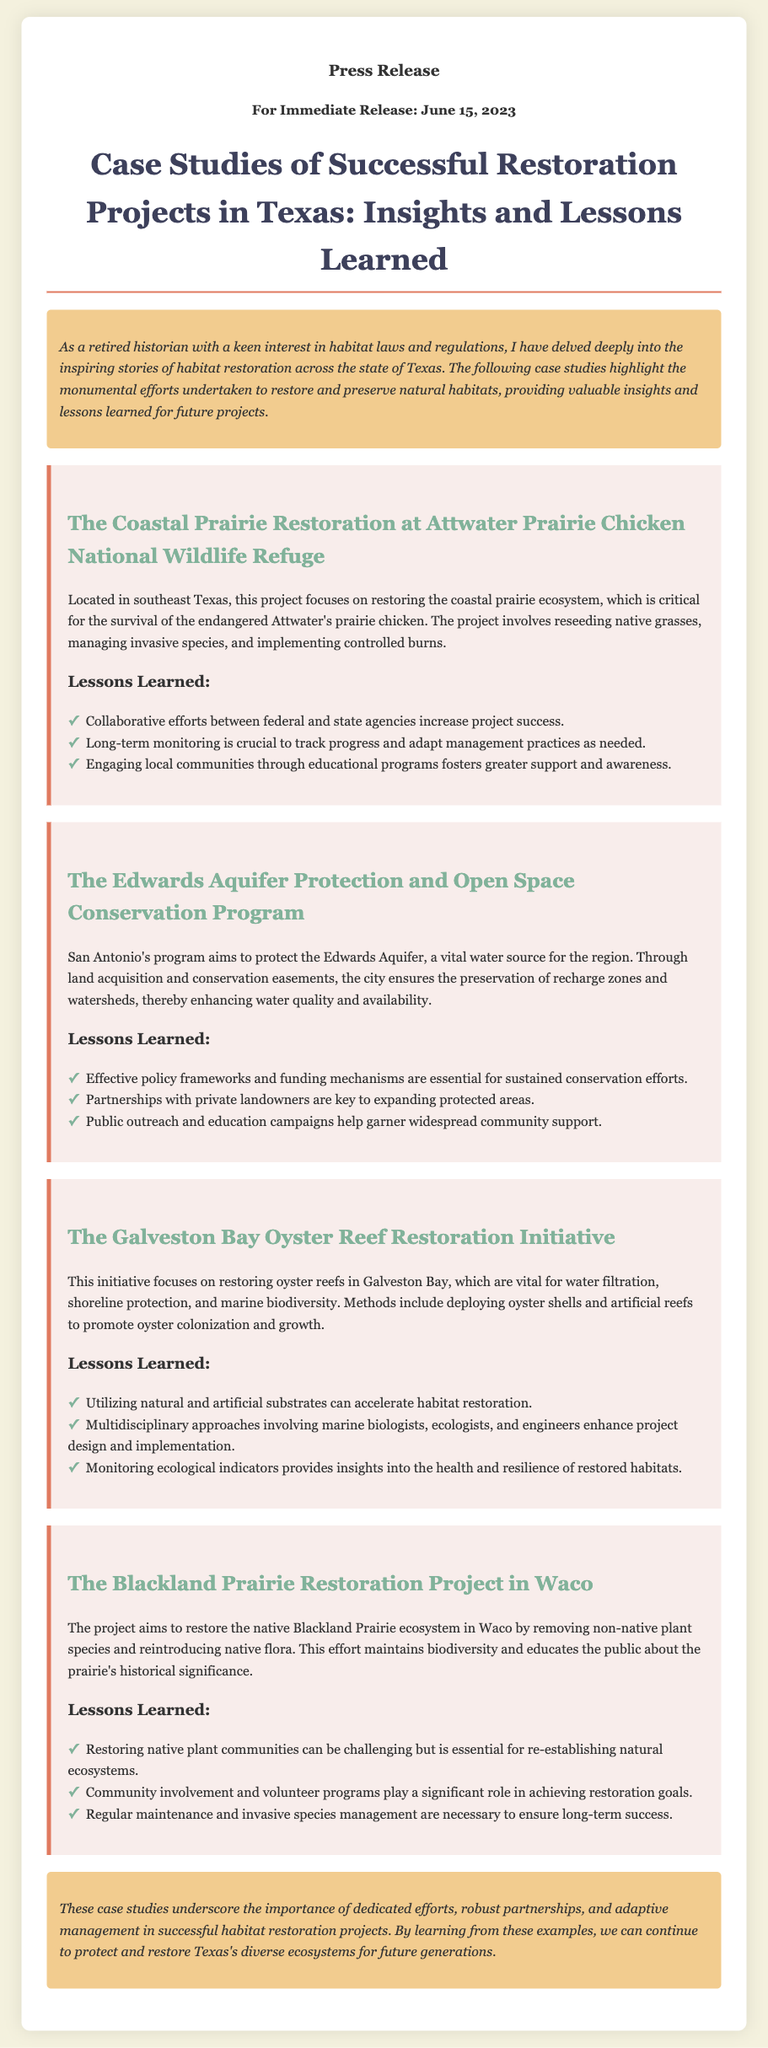What is the title of the press release? The title of the press release provides information about the content covered, which is "Case Studies of Successful Restoration Projects in Texas: Insights and Lessons Learned."
Answer: Case Studies of Successful Restoration Projects in Texas: Insights and Lessons Learned When was the press release issued? The date of the press release is provided at the top, indicating when it was made available to the public.
Answer: June 15, 2023 What is the main focus of the coastal prairie restoration project? The main focus is to restore the coastal prairie ecosystem, critical for the survival of the endangered species mentioned.
Answer: Endangered Attwater's prairie chicken What are two key lessons learned from the Edwards Aquifer project? Two lessons learned from the Edwards Aquifer project highlight the importance of policy frameworks and partnerships with landowners.
Answer: Effective policy frameworks and funding mechanisms; Partnerships with private landowners Which ecosystem is being restored in the Blackland Prairie Restoration Project? The specific ecosystem being restored is highlighted at the beginning of the corresponding case study.
Answer: Blackland Prairie Ecosystem What type of restoration methods are used in the Galveston Bay initiative? The types of restoration methods mentioned include deploying oyster shells and artificial reefs to promote colonization.
Answer: Deploying oyster shells and artificial reefs What aspect of community involvement is emphasized in the conclusion? The conclusion mentions the importance of community support and educational programs as vital components of successful restoration projects.
Answer: Community involvement and educational programs How is the coastal prairie restoration project distinguished geographically? The document specifies that the project is located in southeast Texas, providing geographical context.
Answer: Southeast Texas 